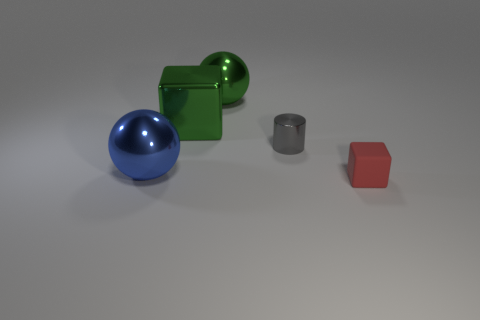What colors are the objects in the image? The image features objects in several colors: there's a blue sphere, a green cube, a gray cylinder, and a red cube. 